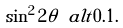Convert formula to latex. <formula><loc_0><loc_0><loc_500><loc_500>\sin ^ { 2 } 2 \theta \ a l t 0 . 1 .</formula> 